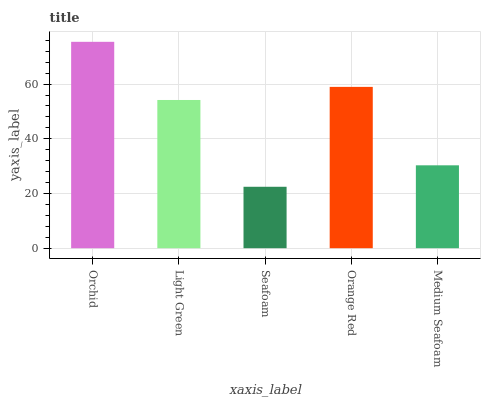Is Light Green the minimum?
Answer yes or no. No. Is Light Green the maximum?
Answer yes or no. No. Is Orchid greater than Light Green?
Answer yes or no. Yes. Is Light Green less than Orchid?
Answer yes or no. Yes. Is Light Green greater than Orchid?
Answer yes or no. No. Is Orchid less than Light Green?
Answer yes or no. No. Is Light Green the high median?
Answer yes or no. Yes. Is Light Green the low median?
Answer yes or no. Yes. Is Medium Seafoam the high median?
Answer yes or no. No. Is Orange Red the low median?
Answer yes or no. No. 